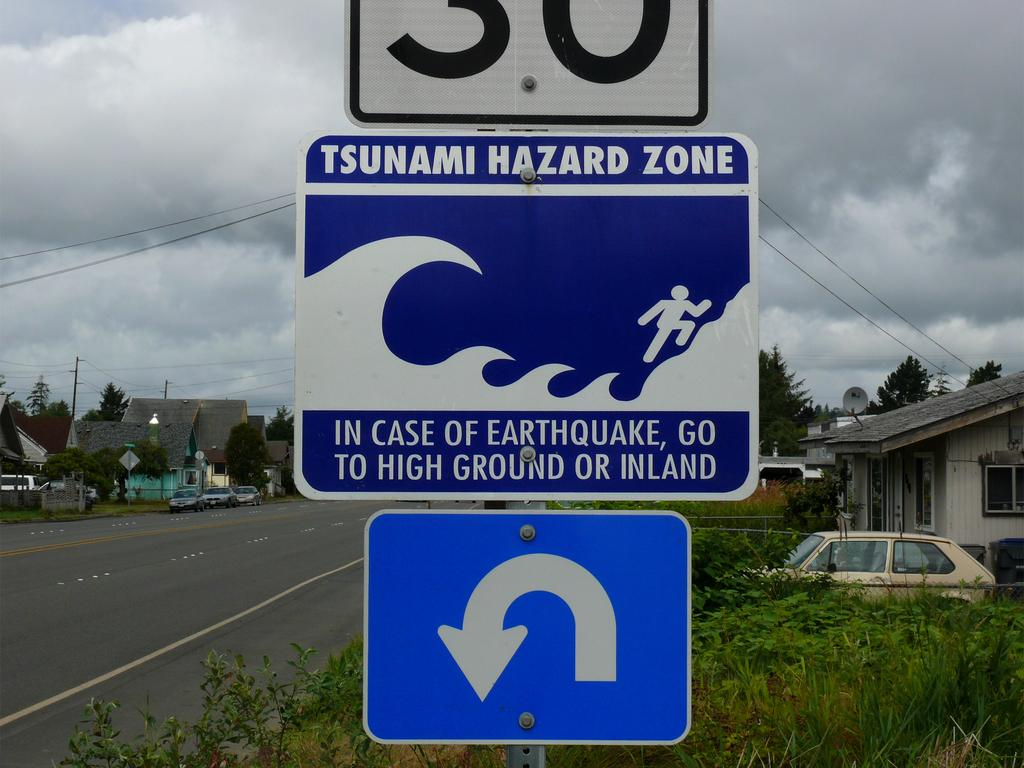<image>
Share a concise interpretation of the image provided. A tsunami warning sign is shown telling people to seek higher ground or go inland after an earthquake to avoid a large ocean wave. 